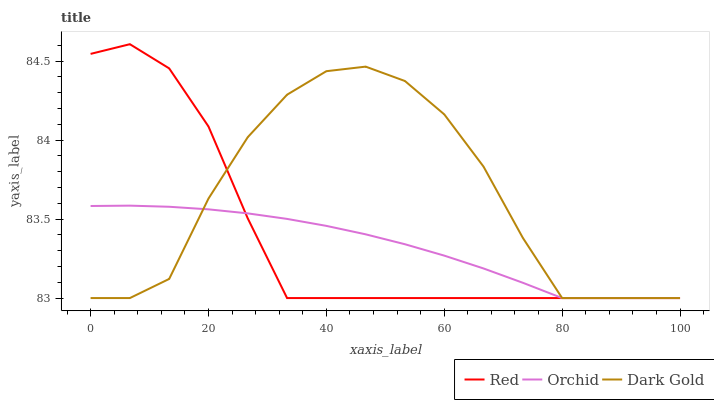Does Orchid have the minimum area under the curve?
Answer yes or no. Yes. Does Dark Gold have the maximum area under the curve?
Answer yes or no. Yes. Does Red have the minimum area under the curve?
Answer yes or no. No. Does Red have the maximum area under the curve?
Answer yes or no. No. Is Orchid the smoothest?
Answer yes or no. Yes. Is Dark Gold the roughest?
Answer yes or no. Yes. Is Red the smoothest?
Answer yes or no. No. Is Red the roughest?
Answer yes or no. No. Does Dark Gold have the lowest value?
Answer yes or no. Yes. Does Red have the highest value?
Answer yes or no. Yes. Does Orchid have the highest value?
Answer yes or no. No. Does Dark Gold intersect Orchid?
Answer yes or no. Yes. Is Dark Gold less than Orchid?
Answer yes or no. No. Is Dark Gold greater than Orchid?
Answer yes or no. No. 